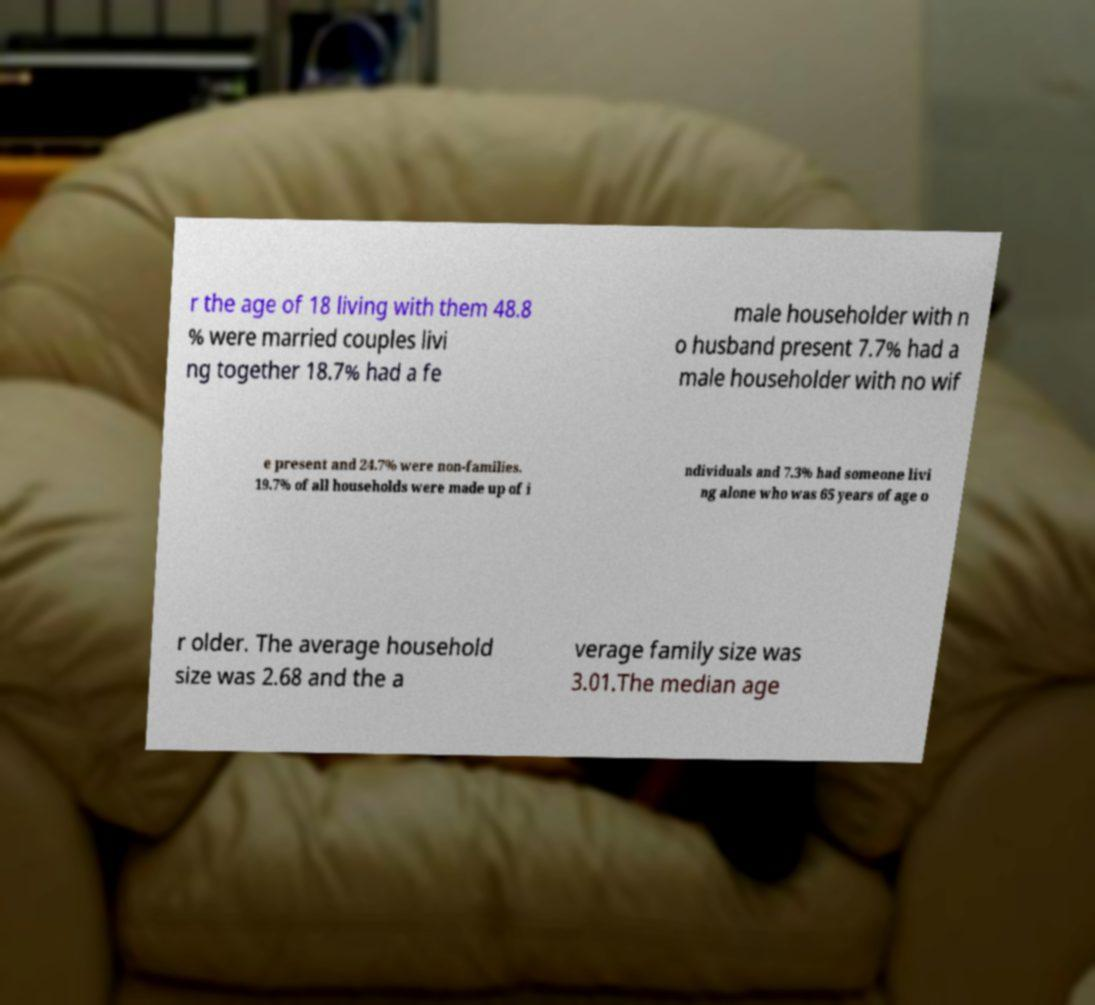Can you read and provide the text displayed in the image?This photo seems to have some interesting text. Can you extract and type it out for me? r the age of 18 living with them 48.8 % were married couples livi ng together 18.7% had a fe male householder with n o husband present 7.7% had a male householder with no wif e present and 24.7% were non-families. 19.7% of all households were made up of i ndividuals and 7.3% had someone livi ng alone who was 65 years of age o r older. The average household size was 2.68 and the a verage family size was 3.01.The median age 